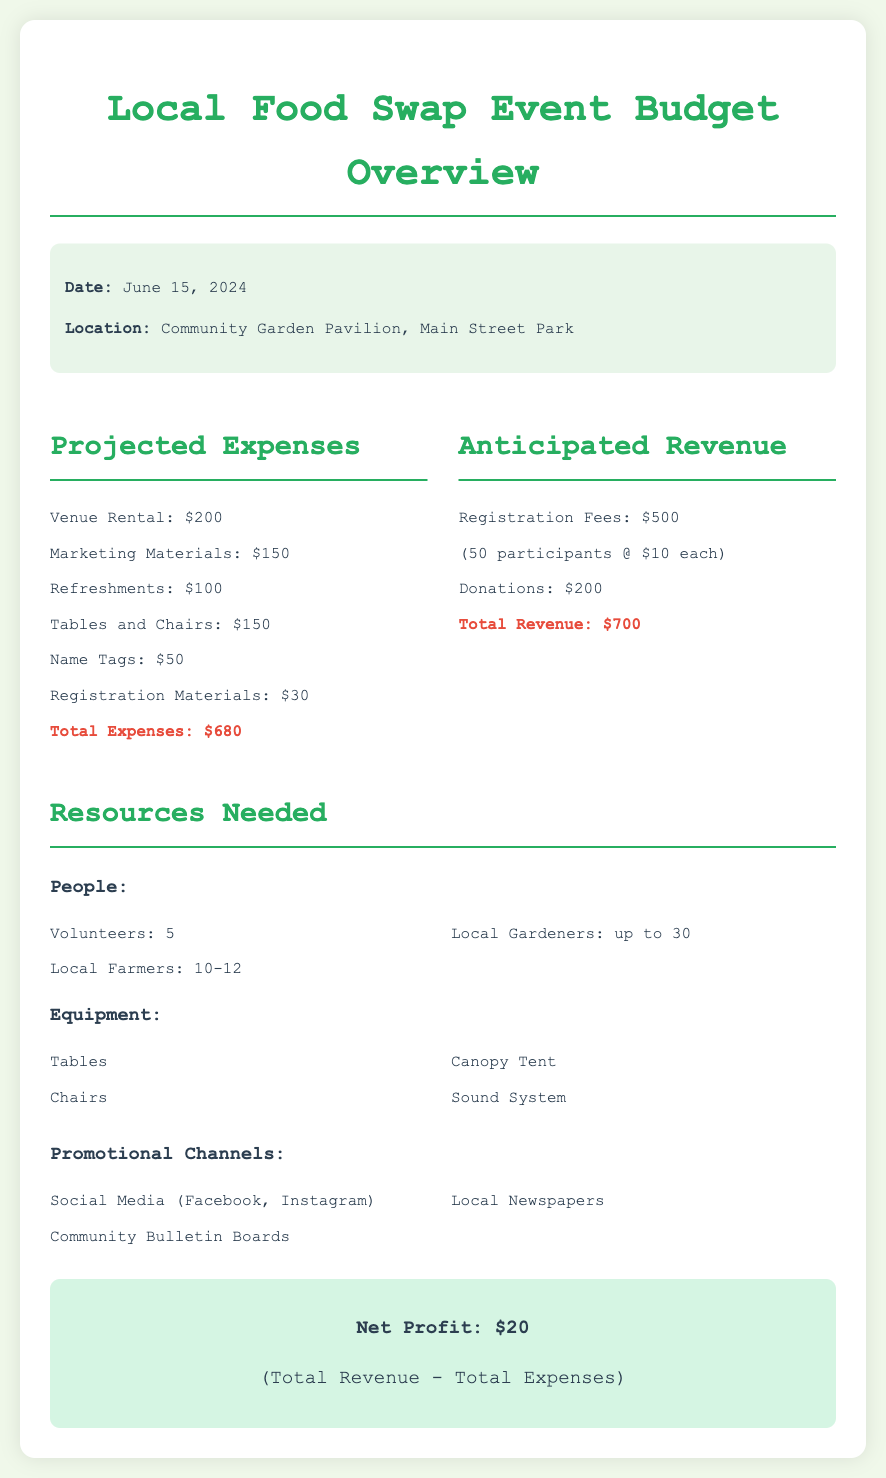What is the event date? The event date is explicitly mentioned in the document.
Answer: June 15, 2024 What is the location of the event? The location of the event is clearly stated in the details section.
Answer: Community Garden Pavilion, Main Street Park What are the total projected expenses? The total projected expenses is summarized at the end of the expenses section.
Answer: $680 What are the anticipated registration fees? The anticipated registration fees are detailed in the revenue section, specifying participants and fee per participant.
Answer: $500 What is the number of volunteers needed? The number of volunteers is listed under the resources needed section in the people category.
Answer: 5 What is the net profit from the event? The net profit is explicitly calculated at the end of the budget overview.
Answer: $20 What resources are needed for the event? Resources such as people, equipment, and promotional channels are listed in their respective sections.
Answer: Volunteers, Local Farmers, Local Gardeners How many participants are expected? The expected number of participants is mentioned in the revenue section alongside the fees.
Answer: 50 What is the total revenue generated from donations? The total revenue from donations is highlighted in the anticipated revenue section.
Answer: $200 What type of document is this? This document serves as a budget overview for an event.
Answer: Budget Overview 